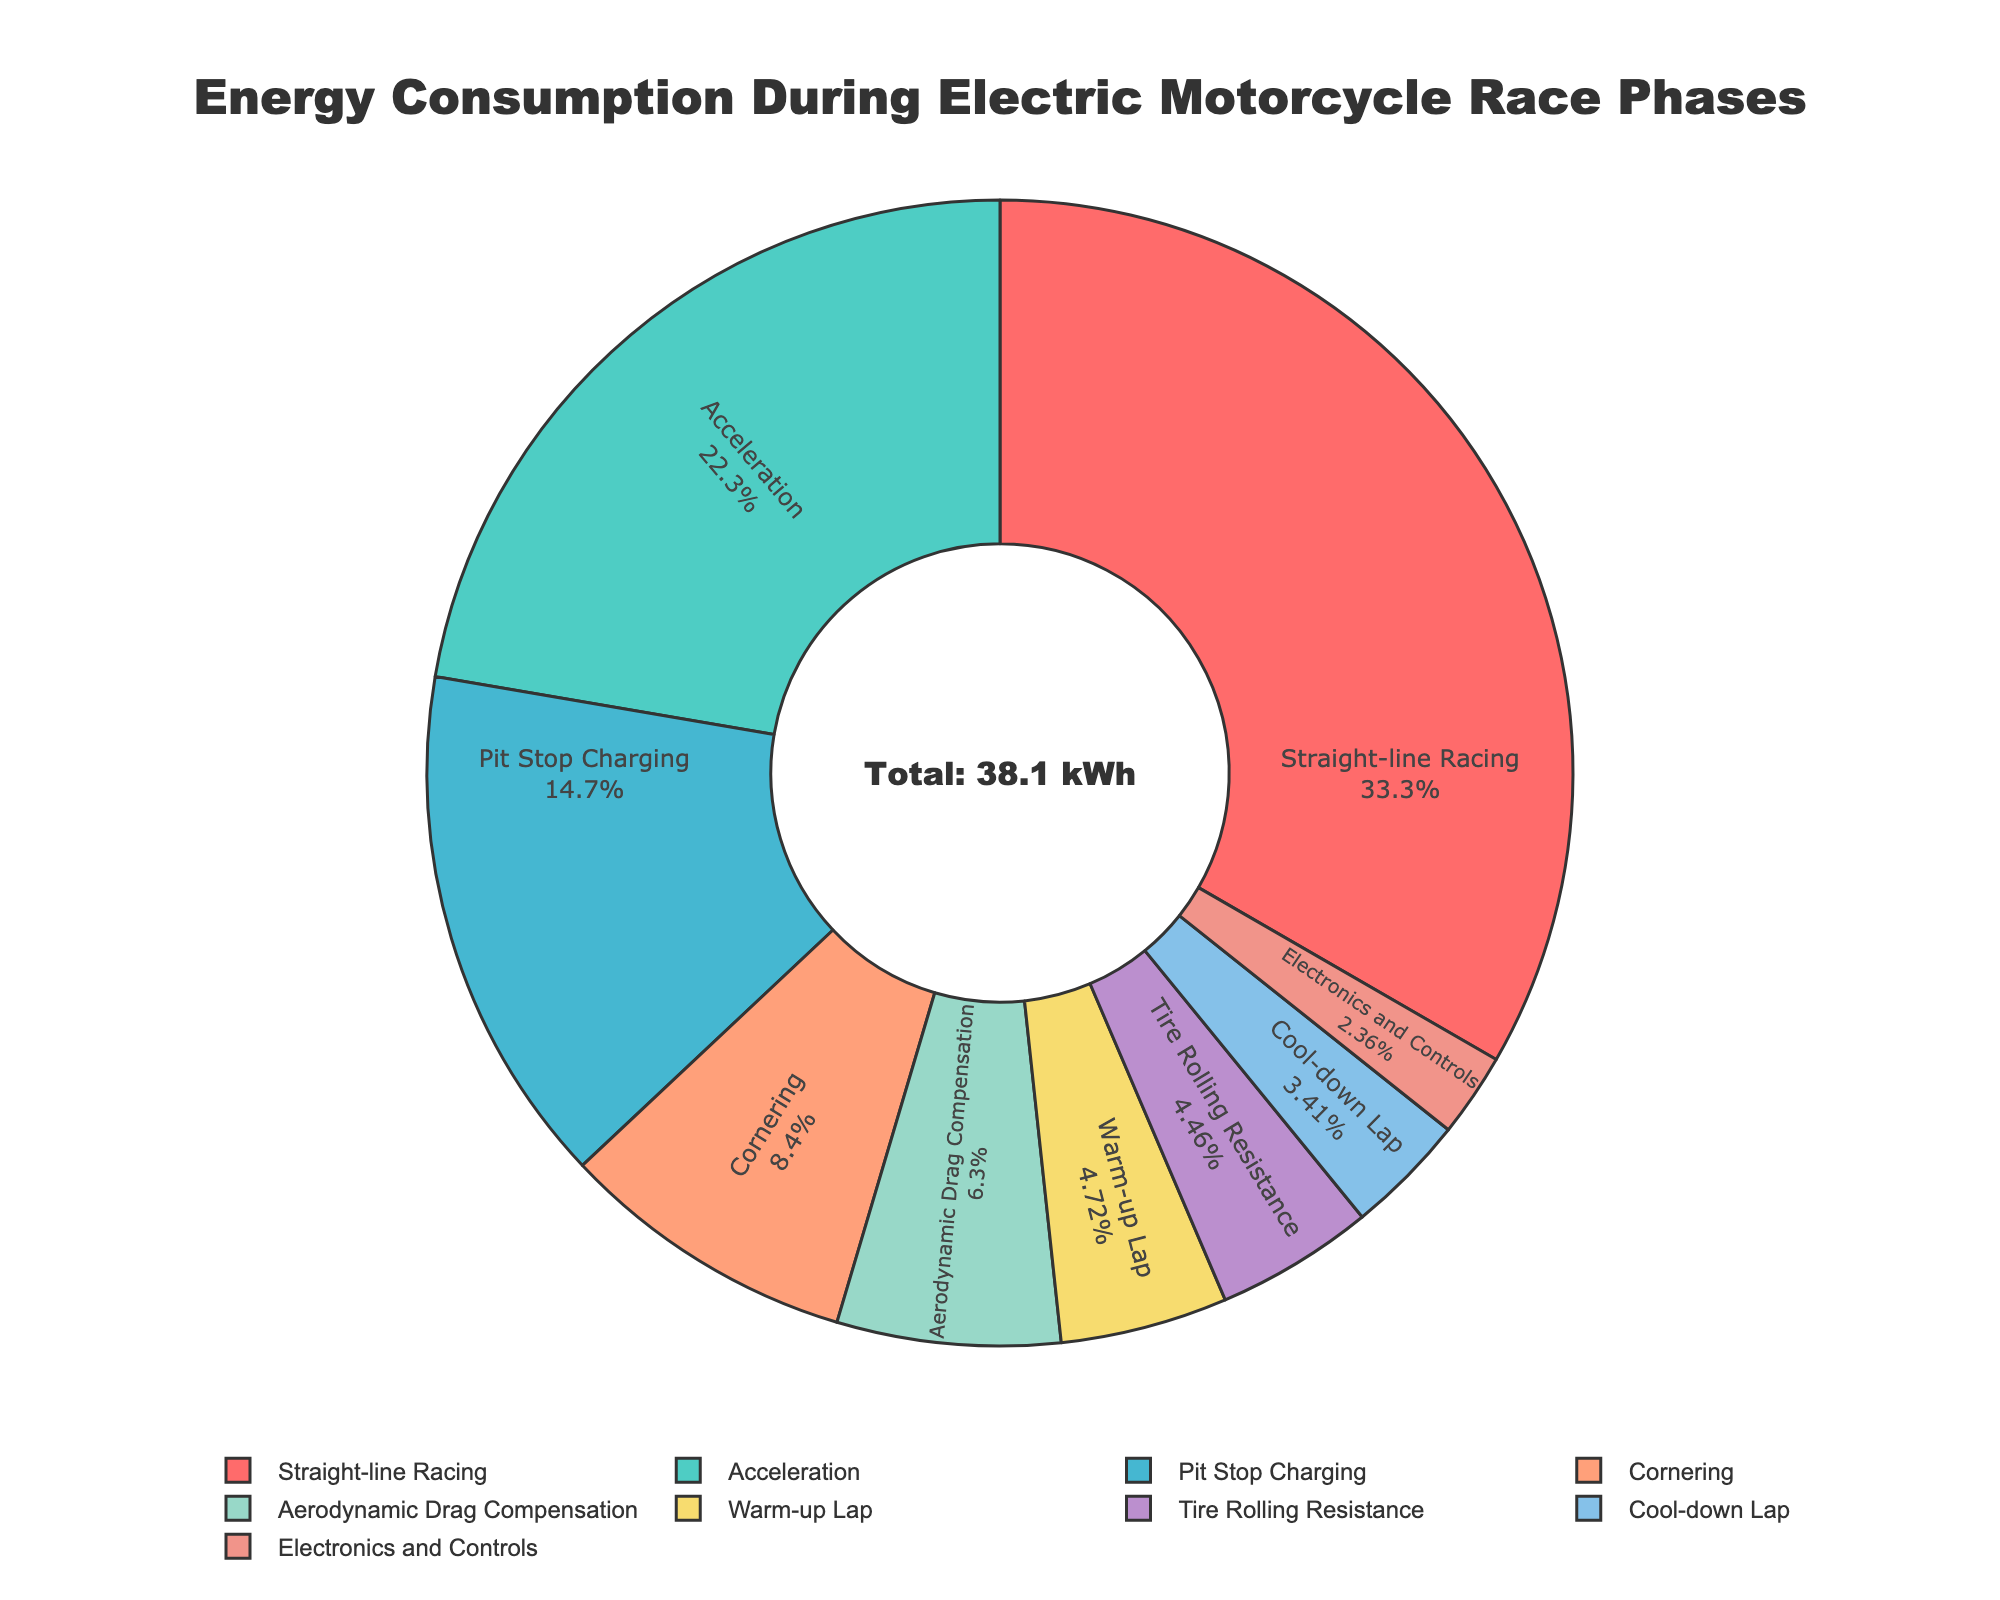What's the total energy consumption excluding braking regeneration? To find the total energy consumption excluding braking regeneration, sum all the positive values: 8.5 (Acceleration) + 3.2 (Cornering) + 12.7 (Straight-line Racing) + 5.6 (Pit Stop Charging) + 1.8 (Warm-up Lap) + 1.3 (Cool-down Lap) + 0.9 (Electronics and Controls) + 2.4 (Aerodynamic Drag Compensation) + 1.7 (Tire Rolling Resistance). The sum is 38.1 kWh.
Answer: 38.1 kWh Which phase has the highest energy consumption, and what is the value? The phase with the highest energy consumption is identified by the largest wedge in the pie chart. Straight-line Racing has the highest energy consumption at 12.7 kWh.
Answer: Straight-line Racing, 12.7 kWh How does the energy consumption for acceleration compare to cornering? Acceleration consumes 8.5 kWh, and cornering consumes 3.2 kWh. Therefore, acceleration consumes more energy than cornering.
Answer: Acceleration consumes more What percentage of total energy is used for pit stop charging? First, calculate the total positive energy consumption, which is 38.1 kWh. The percentage for pit stop charging is calculated as (5.6 / 38.1) * 100 = approximately 14.7%.
Answer: Approximately 14.7% What is the combined energy consumption for the warm-up lap and cool-down lap? Add the energy consumption of both phases: 1.8 (Warm-up Lap) + 1.3 (Cool-down Lap). The combined consumption is 3.1 kWh.
Answer: 3.1 kWh What is the smallest energy-consuming phase, and what does it consume? The smallest energy-consuming phase is identified by the smallest wedge in the pie chart, which is Electronics and Controls at 0.9 kWh.
Answer: Electronics and Controls, 0.9 kWh How much more energy does straight-line racing consume compared to tire rolling resistance? Subtract the energy consumption of tire rolling resistance from straight-line racing: 12.7 (Straight-line Racing) - 1.7 (Tire Rolling Resistance). The difference is 11 kWh.
Answer: 11 kWh Which two phases have the closest energy consumption values, and what are their consumptions? Cornering and Aerodynamic Drag Compensation have quite close energy consumptions. Cornering consumes 3.2 kWh, and Aerodynamic Drag Compensation consumes 2.4 kWh.
Answer: Cornering: 3.2 kWh, Aerodynamic Drag Compensation: 2.4 kWh 